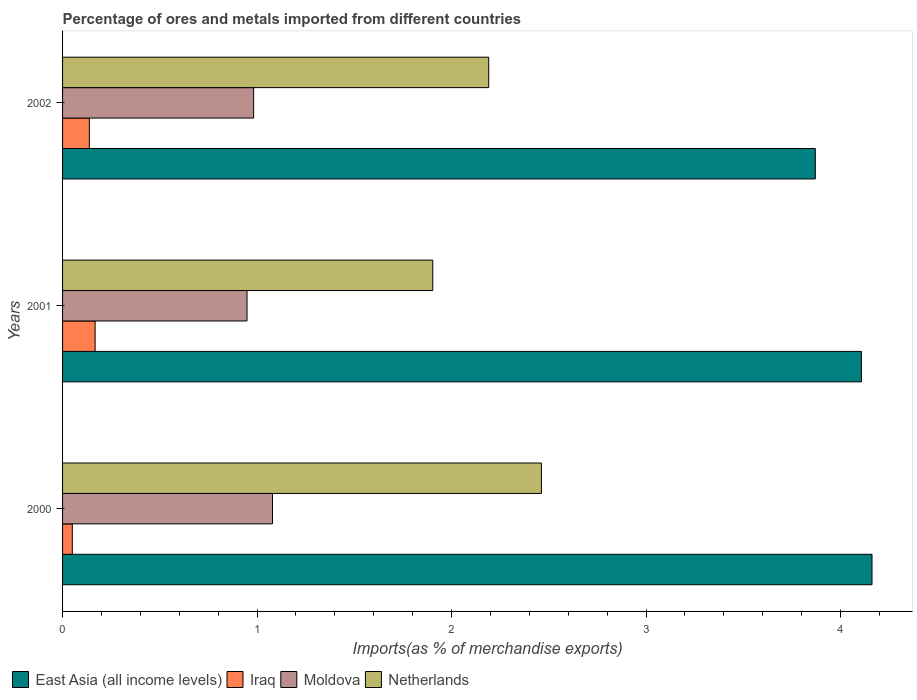Are the number of bars per tick equal to the number of legend labels?
Make the answer very short. Yes. Are the number of bars on each tick of the Y-axis equal?
Ensure brevity in your answer.  Yes. How many bars are there on the 3rd tick from the top?
Provide a short and direct response. 4. How many bars are there on the 2nd tick from the bottom?
Keep it short and to the point. 4. In how many cases, is the number of bars for a given year not equal to the number of legend labels?
Your response must be concise. 0. What is the percentage of imports to different countries in Iraq in 2001?
Provide a short and direct response. 0.17. Across all years, what is the maximum percentage of imports to different countries in Netherlands?
Ensure brevity in your answer.  2.46. Across all years, what is the minimum percentage of imports to different countries in Moldova?
Ensure brevity in your answer.  0.95. What is the total percentage of imports to different countries in Netherlands in the graph?
Your answer should be compact. 6.56. What is the difference between the percentage of imports to different countries in East Asia (all income levels) in 2000 and that in 2002?
Offer a terse response. 0.29. What is the difference between the percentage of imports to different countries in Iraq in 2001 and the percentage of imports to different countries in East Asia (all income levels) in 2002?
Give a very brief answer. -3.7. What is the average percentage of imports to different countries in Moldova per year?
Provide a short and direct response. 1. In the year 2001, what is the difference between the percentage of imports to different countries in Moldova and percentage of imports to different countries in East Asia (all income levels)?
Give a very brief answer. -3.16. In how many years, is the percentage of imports to different countries in East Asia (all income levels) greater than 2 %?
Offer a terse response. 3. What is the ratio of the percentage of imports to different countries in Iraq in 2000 to that in 2002?
Provide a succinct answer. 0.36. What is the difference between the highest and the second highest percentage of imports to different countries in Netherlands?
Your answer should be very brief. 0.27. What is the difference between the highest and the lowest percentage of imports to different countries in Moldova?
Keep it short and to the point. 0.13. In how many years, is the percentage of imports to different countries in Netherlands greater than the average percentage of imports to different countries in Netherlands taken over all years?
Ensure brevity in your answer.  2. Is the sum of the percentage of imports to different countries in East Asia (all income levels) in 2000 and 2002 greater than the maximum percentage of imports to different countries in Netherlands across all years?
Your answer should be compact. Yes. Is it the case that in every year, the sum of the percentage of imports to different countries in Netherlands and percentage of imports to different countries in Iraq is greater than the sum of percentage of imports to different countries in East Asia (all income levels) and percentage of imports to different countries in Moldova?
Offer a terse response. No. What does the 1st bar from the top in 2001 represents?
Keep it short and to the point. Netherlands. What does the 3rd bar from the bottom in 2001 represents?
Your response must be concise. Moldova. How many bars are there?
Give a very brief answer. 12. Are all the bars in the graph horizontal?
Make the answer very short. Yes. How many years are there in the graph?
Provide a succinct answer. 3. Does the graph contain any zero values?
Provide a short and direct response. No. How are the legend labels stacked?
Give a very brief answer. Horizontal. What is the title of the graph?
Give a very brief answer. Percentage of ores and metals imported from different countries. Does "Armenia" appear as one of the legend labels in the graph?
Your answer should be compact. No. What is the label or title of the X-axis?
Offer a terse response. Imports(as % of merchandise exports). What is the label or title of the Y-axis?
Offer a very short reply. Years. What is the Imports(as % of merchandise exports) of East Asia (all income levels) in 2000?
Your response must be concise. 4.16. What is the Imports(as % of merchandise exports) of Iraq in 2000?
Make the answer very short. 0.05. What is the Imports(as % of merchandise exports) of Moldova in 2000?
Provide a short and direct response. 1.08. What is the Imports(as % of merchandise exports) in Netherlands in 2000?
Your response must be concise. 2.46. What is the Imports(as % of merchandise exports) in East Asia (all income levels) in 2001?
Make the answer very short. 4.11. What is the Imports(as % of merchandise exports) in Iraq in 2001?
Offer a terse response. 0.17. What is the Imports(as % of merchandise exports) of Moldova in 2001?
Your answer should be compact. 0.95. What is the Imports(as % of merchandise exports) in Netherlands in 2001?
Offer a very short reply. 1.9. What is the Imports(as % of merchandise exports) in East Asia (all income levels) in 2002?
Your answer should be compact. 3.87. What is the Imports(as % of merchandise exports) in Iraq in 2002?
Provide a succinct answer. 0.14. What is the Imports(as % of merchandise exports) in Moldova in 2002?
Give a very brief answer. 0.98. What is the Imports(as % of merchandise exports) in Netherlands in 2002?
Make the answer very short. 2.19. Across all years, what is the maximum Imports(as % of merchandise exports) in East Asia (all income levels)?
Keep it short and to the point. 4.16. Across all years, what is the maximum Imports(as % of merchandise exports) of Iraq?
Provide a short and direct response. 0.17. Across all years, what is the maximum Imports(as % of merchandise exports) of Moldova?
Offer a very short reply. 1.08. Across all years, what is the maximum Imports(as % of merchandise exports) of Netherlands?
Offer a very short reply. 2.46. Across all years, what is the minimum Imports(as % of merchandise exports) in East Asia (all income levels)?
Keep it short and to the point. 3.87. Across all years, what is the minimum Imports(as % of merchandise exports) in Iraq?
Offer a very short reply. 0.05. Across all years, what is the minimum Imports(as % of merchandise exports) in Moldova?
Your answer should be compact. 0.95. Across all years, what is the minimum Imports(as % of merchandise exports) in Netherlands?
Make the answer very short. 1.9. What is the total Imports(as % of merchandise exports) of East Asia (all income levels) in the graph?
Offer a terse response. 12.14. What is the total Imports(as % of merchandise exports) in Iraq in the graph?
Provide a short and direct response. 0.36. What is the total Imports(as % of merchandise exports) in Moldova in the graph?
Make the answer very short. 3.01. What is the total Imports(as % of merchandise exports) of Netherlands in the graph?
Ensure brevity in your answer.  6.56. What is the difference between the Imports(as % of merchandise exports) in East Asia (all income levels) in 2000 and that in 2001?
Keep it short and to the point. 0.05. What is the difference between the Imports(as % of merchandise exports) in Iraq in 2000 and that in 2001?
Offer a very short reply. -0.12. What is the difference between the Imports(as % of merchandise exports) of Moldova in 2000 and that in 2001?
Your answer should be compact. 0.13. What is the difference between the Imports(as % of merchandise exports) of Netherlands in 2000 and that in 2001?
Ensure brevity in your answer.  0.56. What is the difference between the Imports(as % of merchandise exports) in East Asia (all income levels) in 2000 and that in 2002?
Keep it short and to the point. 0.29. What is the difference between the Imports(as % of merchandise exports) of Iraq in 2000 and that in 2002?
Keep it short and to the point. -0.09. What is the difference between the Imports(as % of merchandise exports) of Moldova in 2000 and that in 2002?
Offer a very short reply. 0.1. What is the difference between the Imports(as % of merchandise exports) of Netherlands in 2000 and that in 2002?
Offer a very short reply. 0.27. What is the difference between the Imports(as % of merchandise exports) in East Asia (all income levels) in 2001 and that in 2002?
Give a very brief answer. 0.24. What is the difference between the Imports(as % of merchandise exports) in Iraq in 2001 and that in 2002?
Make the answer very short. 0.03. What is the difference between the Imports(as % of merchandise exports) in Moldova in 2001 and that in 2002?
Your answer should be very brief. -0.03. What is the difference between the Imports(as % of merchandise exports) of Netherlands in 2001 and that in 2002?
Provide a short and direct response. -0.29. What is the difference between the Imports(as % of merchandise exports) of East Asia (all income levels) in 2000 and the Imports(as % of merchandise exports) of Iraq in 2001?
Keep it short and to the point. 3.99. What is the difference between the Imports(as % of merchandise exports) in East Asia (all income levels) in 2000 and the Imports(as % of merchandise exports) in Moldova in 2001?
Keep it short and to the point. 3.21. What is the difference between the Imports(as % of merchandise exports) in East Asia (all income levels) in 2000 and the Imports(as % of merchandise exports) in Netherlands in 2001?
Your answer should be very brief. 2.26. What is the difference between the Imports(as % of merchandise exports) in Iraq in 2000 and the Imports(as % of merchandise exports) in Moldova in 2001?
Your answer should be compact. -0.9. What is the difference between the Imports(as % of merchandise exports) of Iraq in 2000 and the Imports(as % of merchandise exports) of Netherlands in 2001?
Your answer should be compact. -1.85. What is the difference between the Imports(as % of merchandise exports) in Moldova in 2000 and the Imports(as % of merchandise exports) in Netherlands in 2001?
Offer a terse response. -0.82. What is the difference between the Imports(as % of merchandise exports) in East Asia (all income levels) in 2000 and the Imports(as % of merchandise exports) in Iraq in 2002?
Ensure brevity in your answer.  4.02. What is the difference between the Imports(as % of merchandise exports) in East Asia (all income levels) in 2000 and the Imports(as % of merchandise exports) in Moldova in 2002?
Keep it short and to the point. 3.18. What is the difference between the Imports(as % of merchandise exports) in East Asia (all income levels) in 2000 and the Imports(as % of merchandise exports) in Netherlands in 2002?
Offer a very short reply. 1.97. What is the difference between the Imports(as % of merchandise exports) of Iraq in 2000 and the Imports(as % of merchandise exports) of Moldova in 2002?
Provide a succinct answer. -0.93. What is the difference between the Imports(as % of merchandise exports) of Iraq in 2000 and the Imports(as % of merchandise exports) of Netherlands in 2002?
Make the answer very short. -2.14. What is the difference between the Imports(as % of merchandise exports) in Moldova in 2000 and the Imports(as % of merchandise exports) in Netherlands in 2002?
Give a very brief answer. -1.11. What is the difference between the Imports(as % of merchandise exports) of East Asia (all income levels) in 2001 and the Imports(as % of merchandise exports) of Iraq in 2002?
Provide a short and direct response. 3.97. What is the difference between the Imports(as % of merchandise exports) of East Asia (all income levels) in 2001 and the Imports(as % of merchandise exports) of Moldova in 2002?
Provide a short and direct response. 3.13. What is the difference between the Imports(as % of merchandise exports) of East Asia (all income levels) in 2001 and the Imports(as % of merchandise exports) of Netherlands in 2002?
Ensure brevity in your answer.  1.92. What is the difference between the Imports(as % of merchandise exports) in Iraq in 2001 and the Imports(as % of merchandise exports) in Moldova in 2002?
Ensure brevity in your answer.  -0.81. What is the difference between the Imports(as % of merchandise exports) in Iraq in 2001 and the Imports(as % of merchandise exports) in Netherlands in 2002?
Give a very brief answer. -2.02. What is the difference between the Imports(as % of merchandise exports) of Moldova in 2001 and the Imports(as % of merchandise exports) of Netherlands in 2002?
Keep it short and to the point. -1.24. What is the average Imports(as % of merchandise exports) of East Asia (all income levels) per year?
Your answer should be compact. 4.05. What is the average Imports(as % of merchandise exports) of Iraq per year?
Offer a very short reply. 0.12. What is the average Imports(as % of merchandise exports) of Netherlands per year?
Provide a succinct answer. 2.19. In the year 2000, what is the difference between the Imports(as % of merchandise exports) in East Asia (all income levels) and Imports(as % of merchandise exports) in Iraq?
Your answer should be very brief. 4.11. In the year 2000, what is the difference between the Imports(as % of merchandise exports) in East Asia (all income levels) and Imports(as % of merchandise exports) in Moldova?
Give a very brief answer. 3.08. In the year 2000, what is the difference between the Imports(as % of merchandise exports) in East Asia (all income levels) and Imports(as % of merchandise exports) in Netherlands?
Your answer should be compact. 1.7. In the year 2000, what is the difference between the Imports(as % of merchandise exports) in Iraq and Imports(as % of merchandise exports) in Moldova?
Offer a terse response. -1.03. In the year 2000, what is the difference between the Imports(as % of merchandise exports) of Iraq and Imports(as % of merchandise exports) of Netherlands?
Provide a succinct answer. -2.41. In the year 2000, what is the difference between the Imports(as % of merchandise exports) in Moldova and Imports(as % of merchandise exports) in Netherlands?
Give a very brief answer. -1.38. In the year 2001, what is the difference between the Imports(as % of merchandise exports) in East Asia (all income levels) and Imports(as % of merchandise exports) in Iraq?
Your answer should be compact. 3.94. In the year 2001, what is the difference between the Imports(as % of merchandise exports) of East Asia (all income levels) and Imports(as % of merchandise exports) of Moldova?
Make the answer very short. 3.16. In the year 2001, what is the difference between the Imports(as % of merchandise exports) of East Asia (all income levels) and Imports(as % of merchandise exports) of Netherlands?
Give a very brief answer. 2.2. In the year 2001, what is the difference between the Imports(as % of merchandise exports) in Iraq and Imports(as % of merchandise exports) in Moldova?
Provide a short and direct response. -0.78. In the year 2001, what is the difference between the Imports(as % of merchandise exports) of Iraq and Imports(as % of merchandise exports) of Netherlands?
Provide a succinct answer. -1.74. In the year 2001, what is the difference between the Imports(as % of merchandise exports) in Moldova and Imports(as % of merchandise exports) in Netherlands?
Your answer should be compact. -0.95. In the year 2002, what is the difference between the Imports(as % of merchandise exports) of East Asia (all income levels) and Imports(as % of merchandise exports) of Iraq?
Your response must be concise. 3.73. In the year 2002, what is the difference between the Imports(as % of merchandise exports) in East Asia (all income levels) and Imports(as % of merchandise exports) in Moldova?
Offer a very short reply. 2.89. In the year 2002, what is the difference between the Imports(as % of merchandise exports) of East Asia (all income levels) and Imports(as % of merchandise exports) of Netherlands?
Ensure brevity in your answer.  1.68. In the year 2002, what is the difference between the Imports(as % of merchandise exports) in Iraq and Imports(as % of merchandise exports) in Moldova?
Offer a very short reply. -0.84. In the year 2002, what is the difference between the Imports(as % of merchandise exports) of Iraq and Imports(as % of merchandise exports) of Netherlands?
Your response must be concise. -2.05. In the year 2002, what is the difference between the Imports(as % of merchandise exports) in Moldova and Imports(as % of merchandise exports) in Netherlands?
Your answer should be very brief. -1.21. What is the ratio of the Imports(as % of merchandise exports) in East Asia (all income levels) in 2000 to that in 2001?
Ensure brevity in your answer.  1.01. What is the ratio of the Imports(as % of merchandise exports) in Iraq in 2000 to that in 2001?
Offer a terse response. 0.3. What is the ratio of the Imports(as % of merchandise exports) of Moldova in 2000 to that in 2001?
Provide a short and direct response. 1.14. What is the ratio of the Imports(as % of merchandise exports) in Netherlands in 2000 to that in 2001?
Give a very brief answer. 1.29. What is the ratio of the Imports(as % of merchandise exports) of East Asia (all income levels) in 2000 to that in 2002?
Your answer should be very brief. 1.08. What is the ratio of the Imports(as % of merchandise exports) in Iraq in 2000 to that in 2002?
Your answer should be compact. 0.36. What is the ratio of the Imports(as % of merchandise exports) of Moldova in 2000 to that in 2002?
Keep it short and to the point. 1.1. What is the ratio of the Imports(as % of merchandise exports) of Netherlands in 2000 to that in 2002?
Ensure brevity in your answer.  1.12. What is the ratio of the Imports(as % of merchandise exports) in East Asia (all income levels) in 2001 to that in 2002?
Make the answer very short. 1.06. What is the ratio of the Imports(as % of merchandise exports) of Iraq in 2001 to that in 2002?
Provide a short and direct response. 1.22. What is the ratio of the Imports(as % of merchandise exports) in Moldova in 2001 to that in 2002?
Your response must be concise. 0.97. What is the ratio of the Imports(as % of merchandise exports) of Netherlands in 2001 to that in 2002?
Provide a succinct answer. 0.87. What is the difference between the highest and the second highest Imports(as % of merchandise exports) in East Asia (all income levels)?
Keep it short and to the point. 0.05. What is the difference between the highest and the second highest Imports(as % of merchandise exports) in Iraq?
Keep it short and to the point. 0.03. What is the difference between the highest and the second highest Imports(as % of merchandise exports) of Moldova?
Make the answer very short. 0.1. What is the difference between the highest and the second highest Imports(as % of merchandise exports) in Netherlands?
Your answer should be very brief. 0.27. What is the difference between the highest and the lowest Imports(as % of merchandise exports) in East Asia (all income levels)?
Make the answer very short. 0.29. What is the difference between the highest and the lowest Imports(as % of merchandise exports) in Iraq?
Ensure brevity in your answer.  0.12. What is the difference between the highest and the lowest Imports(as % of merchandise exports) in Moldova?
Make the answer very short. 0.13. What is the difference between the highest and the lowest Imports(as % of merchandise exports) of Netherlands?
Keep it short and to the point. 0.56. 